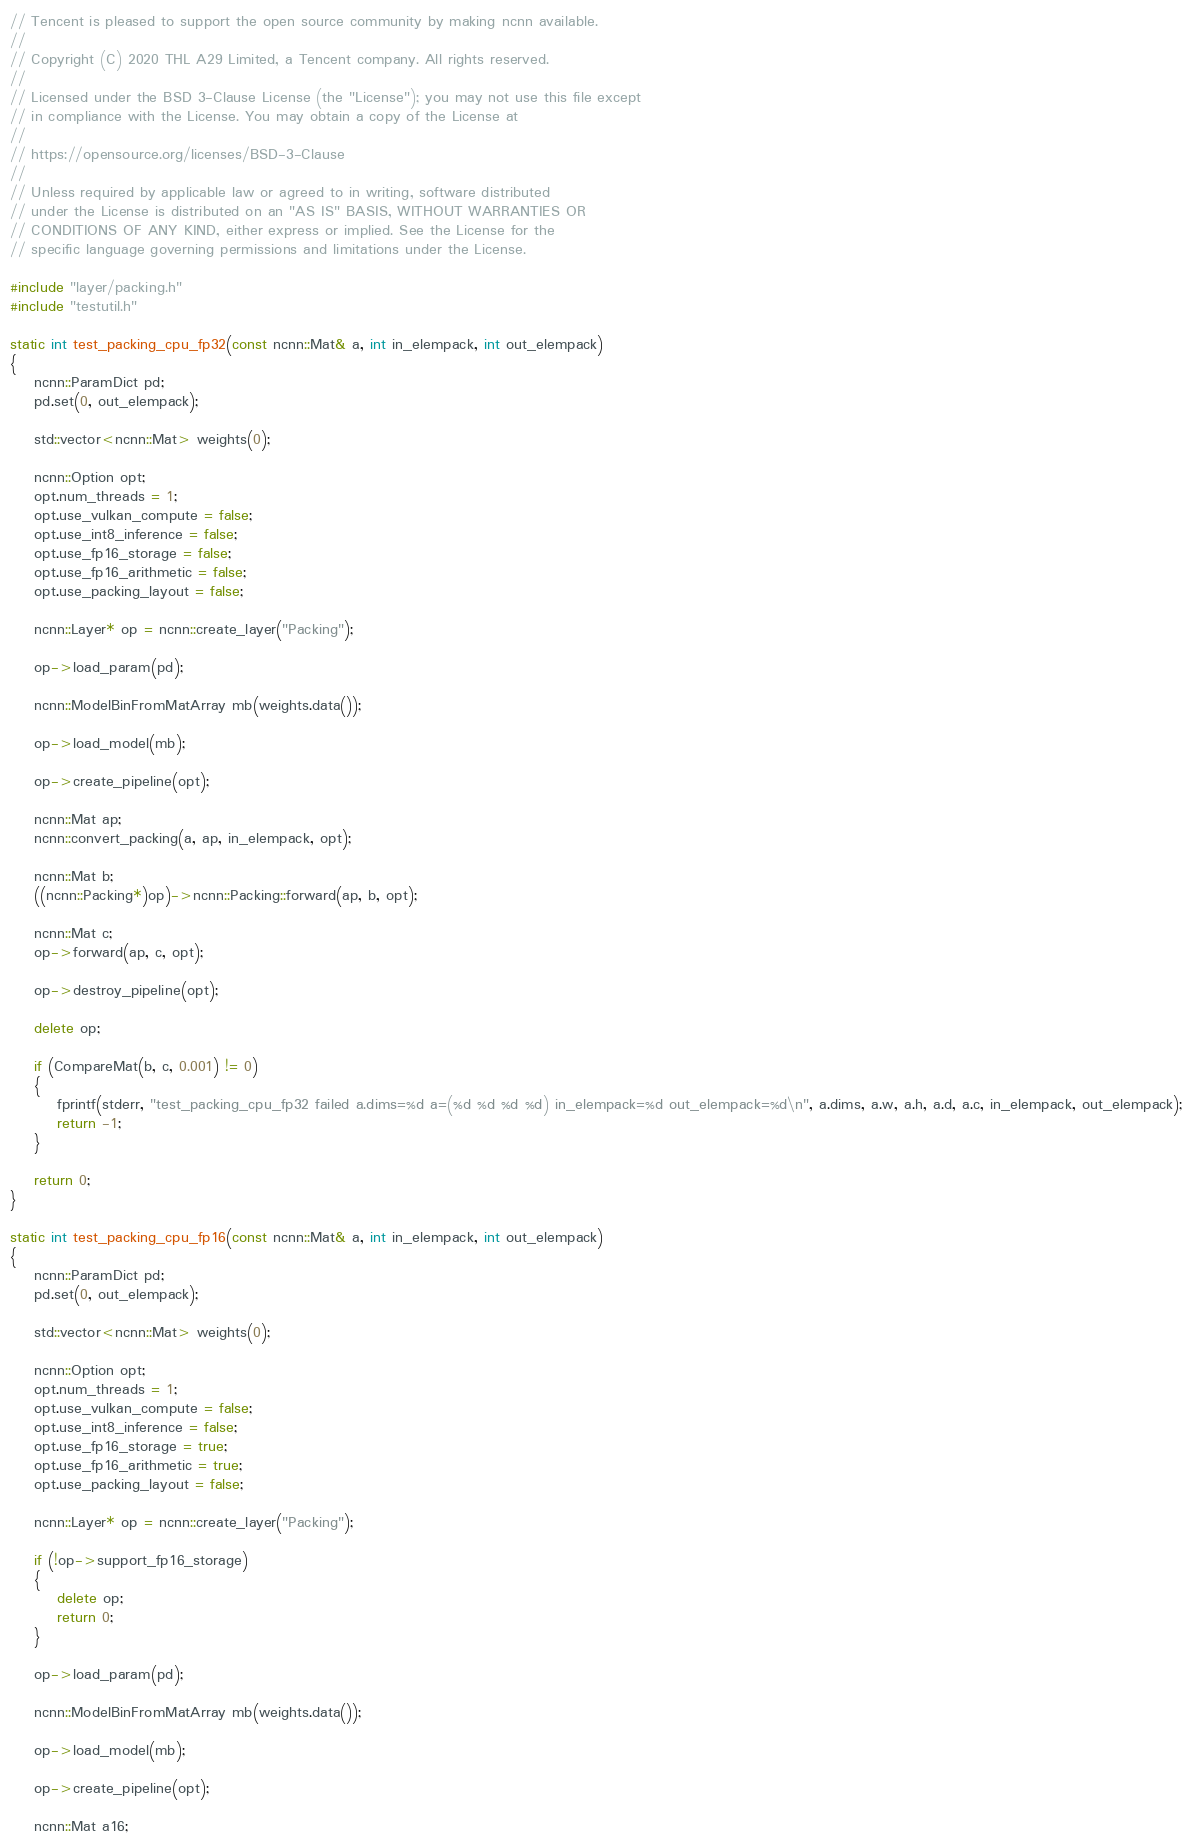Convert code to text. <code><loc_0><loc_0><loc_500><loc_500><_C++_>// Tencent is pleased to support the open source community by making ncnn available.
//
// Copyright (C) 2020 THL A29 Limited, a Tencent company. All rights reserved.
//
// Licensed under the BSD 3-Clause License (the "License"); you may not use this file except
// in compliance with the License. You may obtain a copy of the License at
//
// https://opensource.org/licenses/BSD-3-Clause
//
// Unless required by applicable law or agreed to in writing, software distributed
// under the License is distributed on an "AS IS" BASIS, WITHOUT WARRANTIES OR
// CONDITIONS OF ANY KIND, either express or implied. See the License for the
// specific language governing permissions and limitations under the License.

#include "layer/packing.h"
#include "testutil.h"

static int test_packing_cpu_fp32(const ncnn::Mat& a, int in_elempack, int out_elempack)
{
    ncnn::ParamDict pd;
    pd.set(0, out_elempack);

    std::vector<ncnn::Mat> weights(0);

    ncnn::Option opt;
    opt.num_threads = 1;
    opt.use_vulkan_compute = false;
    opt.use_int8_inference = false;
    opt.use_fp16_storage = false;
    opt.use_fp16_arithmetic = false;
    opt.use_packing_layout = false;

    ncnn::Layer* op = ncnn::create_layer("Packing");

    op->load_param(pd);

    ncnn::ModelBinFromMatArray mb(weights.data());

    op->load_model(mb);

    op->create_pipeline(opt);

    ncnn::Mat ap;
    ncnn::convert_packing(a, ap, in_elempack, opt);

    ncnn::Mat b;
    ((ncnn::Packing*)op)->ncnn::Packing::forward(ap, b, opt);

    ncnn::Mat c;
    op->forward(ap, c, opt);

    op->destroy_pipeline(opt);

    delete op;

    if (CompareMat(b, c, 0.001) != 0)
    {
        fprintf(stderr, "test_packing_cpu_fp32 failed a.dims=%d a=(%d %d %d %d) in_elempack=%d out_elempack=%d\n", a.dims, a.w, a.h, a.d, a.c, in_elempack, out_elempack);
        return -1;
    }

    return 0;
}

static int test_packing_cpu_fp16(const ncnn::Mat& a, int in_elempack, int out_elempack)
{
    ncnn::ParamDict pd;
    pd.set(0, out_elempack);

    std::vector<ncnn::Mat> weights(0);

    ncnn::Option opt;
    opt.num_threads = 1;
    opt.use_vulkan_compute = false;
    opt.use_int8_inference = false;
    opt.use_fp16_storage = true;
    opt.use_fp16_arithmetic = true;
    opt.use_packing_layout = false;

    ncnn::Layer* op = ncnn::create_layer("Packing");

    if (!op->support_fp16_storage)
    {
        delete op;
        return 0;
    }

    op->load_param(pd);

    ncnn::ModelBinFromMatArray mb(weights.data());

    op->load_model(mb);

    op->create_pipeline(opt);

    ncnn::Mat a16;</code> 